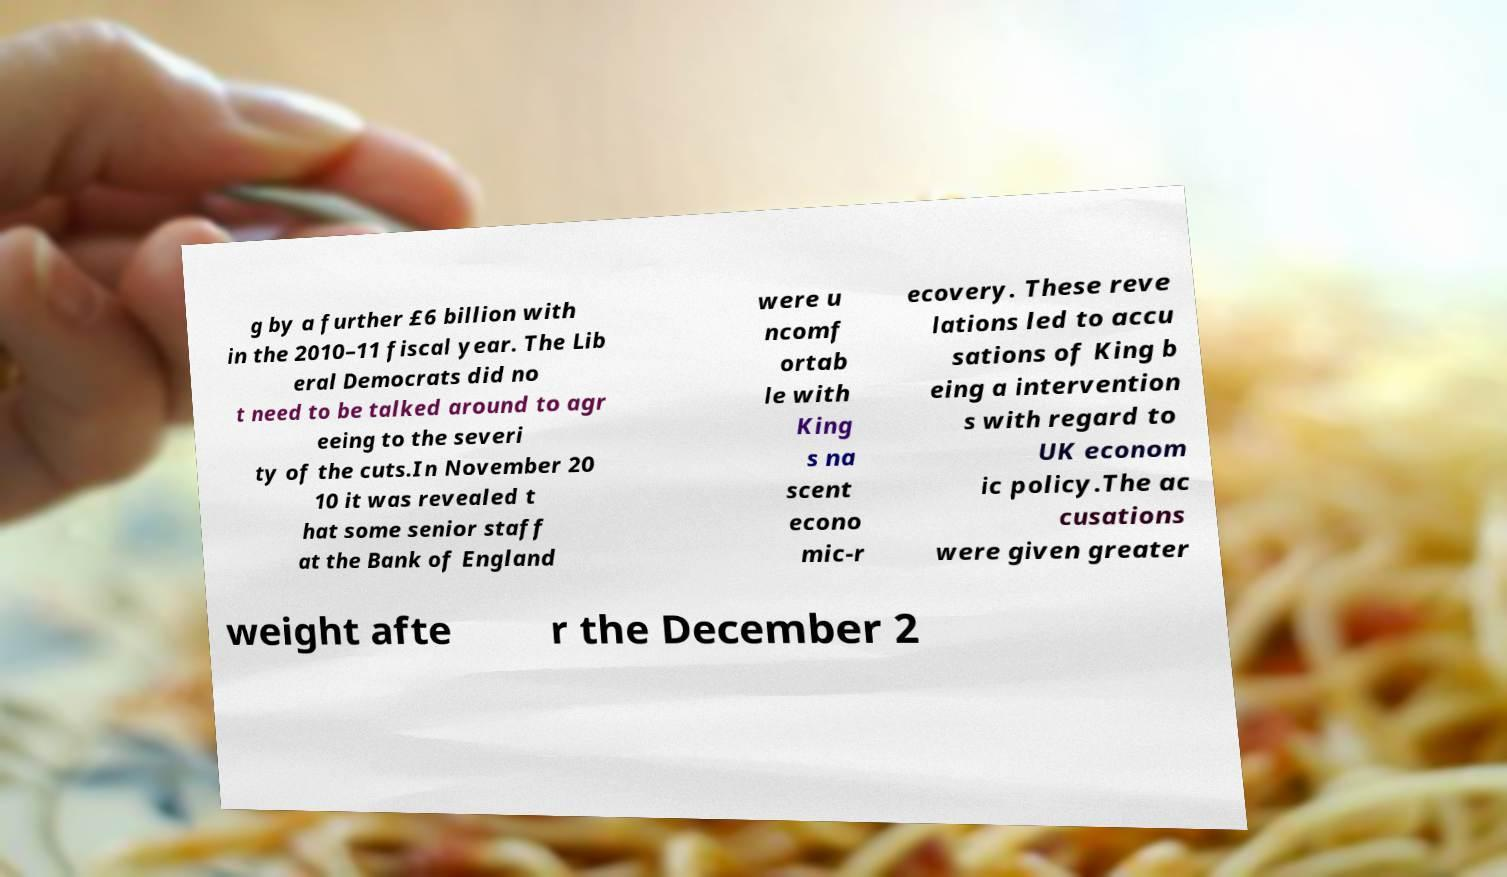Could you assist in decoding the text presented in this image and type it out clearly? g by a further £6 billion with in the 2010–11 fiscal year. The Lib eral Democrats did no t need to be talked around to agr eeing to the severi ty of the cuts.In November 20 10 it was revealed t hat some senior staff at the Bank of England were u ncomf ortab le with King s na scent econo mic-r ecovery. These reve lations led to accu sations of King b eing a intervention s with regard to UK econom ic policy.The ac cusations were given greater weight afte r the December 2 